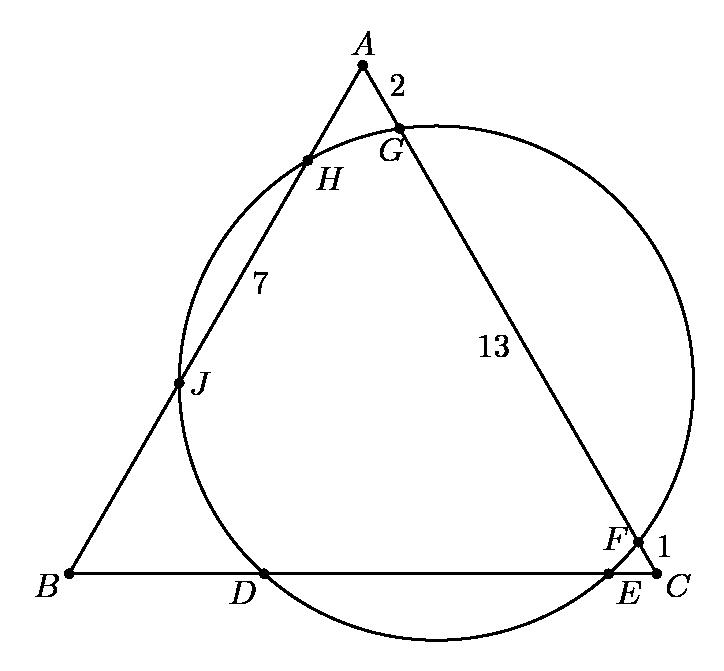Discuss how segment $HJ=7$ impacts the geometry of the entire figure and its analytical implications. $HJ=7$, a segment of one side in the triangle, influences our understanding of the figure’s symmetrical properties. It represents partial length of one side, informating about distances between pivotal points where the circle intersects the triangle. This distance can help calculate other unknown lengths using concepts such as the triangle inequality theorem and similarity ratios within the triangle and circle’s intersecting chords. 